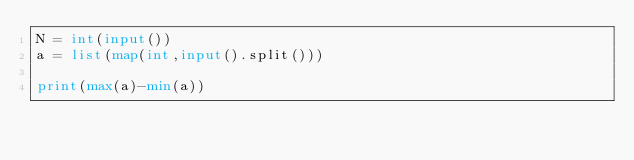<code> <loc_0><loc_0><loc_500><loc_500><_Python_>N = int(input())
a = list(map(int,input().split()))

print(max(a)-min(a))</code> 